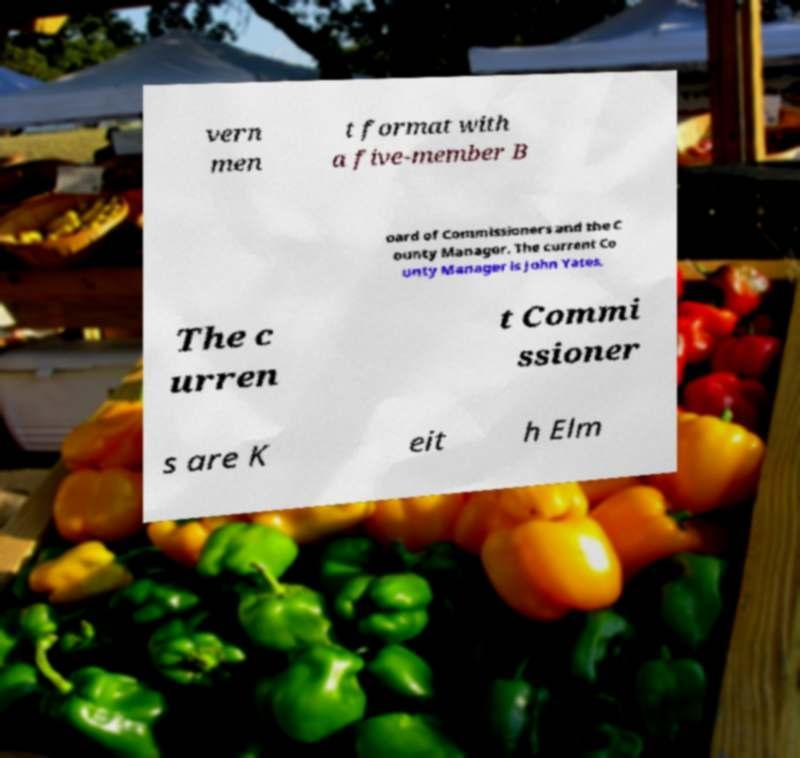Can you read and provide the text displayed in the image?This photo seems to have some interesting text. Can you extract and type it out for me? vern men t format with a five-member B oard of Commissioners and the C ounty Manager. The current Co unty Manager is John Yates. The c urren t Commi ssioner s are K eit h Elm 